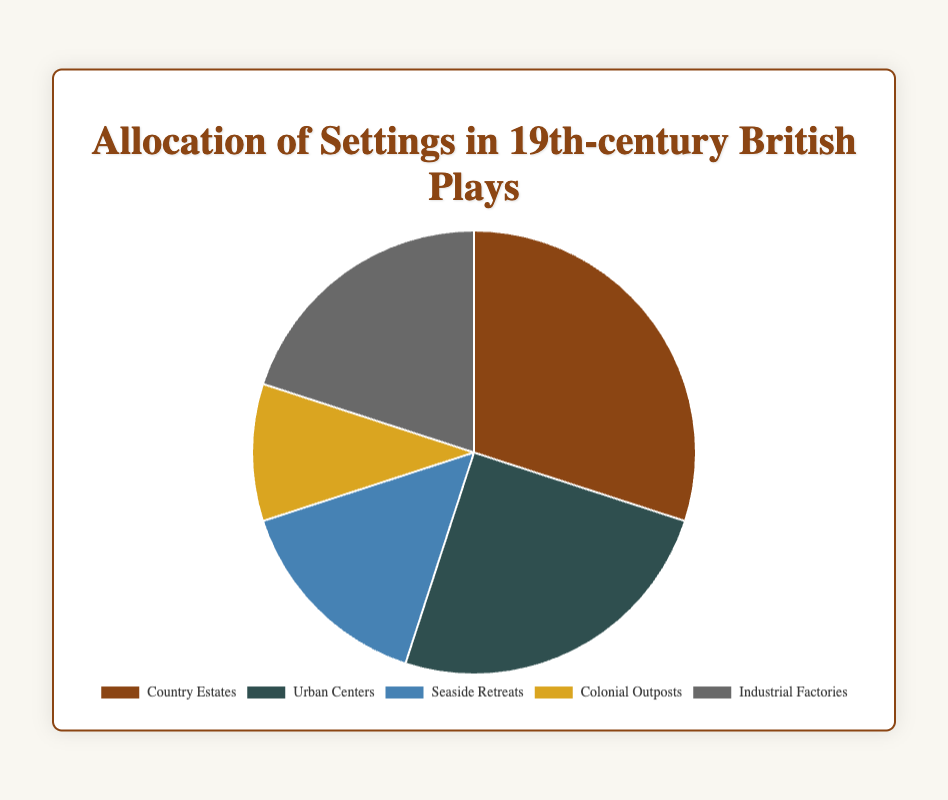Which setting is the most predominant in 19th-century British plays? The "Country Estates" segment of the pie chart is the largest, representing the largest allocation of settings.
Answer: Country Estates How much larger is the percentage of "Industrial Factories" settings compared to "Colonial Outposts"? The pie chart shows "Industrial Factories" at 20% and "Colonial Outposts" at 10%. The difference is 20% - 10% = 10%.
Answer: 10% What percentage of plays set in "Urban Centers" and "Seaside Retreats" combined? The percentages for "Urban Centers" and "Seaside Retreats" are 25% and 15% respectively. Their sum is 25% + 15% = 40%.
Answer: 40% Which settings have the smallest percentage allocation and how much is it? The pie chart indicates that "Colonial Outposts" has the smallest percentage, at 10%.
Answer: Colonial Outposts, 10% Compare the percentages of "Country Estates" and "Urban Centers." Which is greater and by how much? "Country Estates" is 30% and "Urban Centers" is 25%. The difference is 30% - 25% = 5%.
Answer: Country Estates, 5% Which setting is represented by the color brown in the pie chart? The visual attribute of the color brown is used to represent the "Country Estates" setting.
Answer: Country Estates If you were to allocate settings based on the median percentage of the current allocations, what setting would align with that median value? The percentages in ascending order are 10%, 15%, 20%, 25%, and 30%. The median value is the third value, which is 20%, corresponding to "Industrial Factories."
Answer: Industrial Factories Are the "Urban Centers" and "Seaside Retreats" combined percentage more than the "Country Estates" setting? Combining "Urban Centers" (25%) and "Seaside Retreats" (15%) equals 40%, which is higher than "Country Estates" at 30%.
Answer: Yes, 40% is more than 30% What visual element can you use to identify the "Industrial Factories" segment? The "Industrial Factories" segment is represented by a dark grey color in the pie chart.
Answer: Dark grey Which settings together form half of the total percentage allocation? Combining "Country Estates" (30%) and "Urban Centers" (25%) equals 55%, which exceeds half. Combining "Country Estates" (30%) and "Industrial Factories" (20%) equals 50%. So, "Country Estates" and "Industrial Factories" form half of the allocation.
Answer: Country Estates and Industrial Factories 